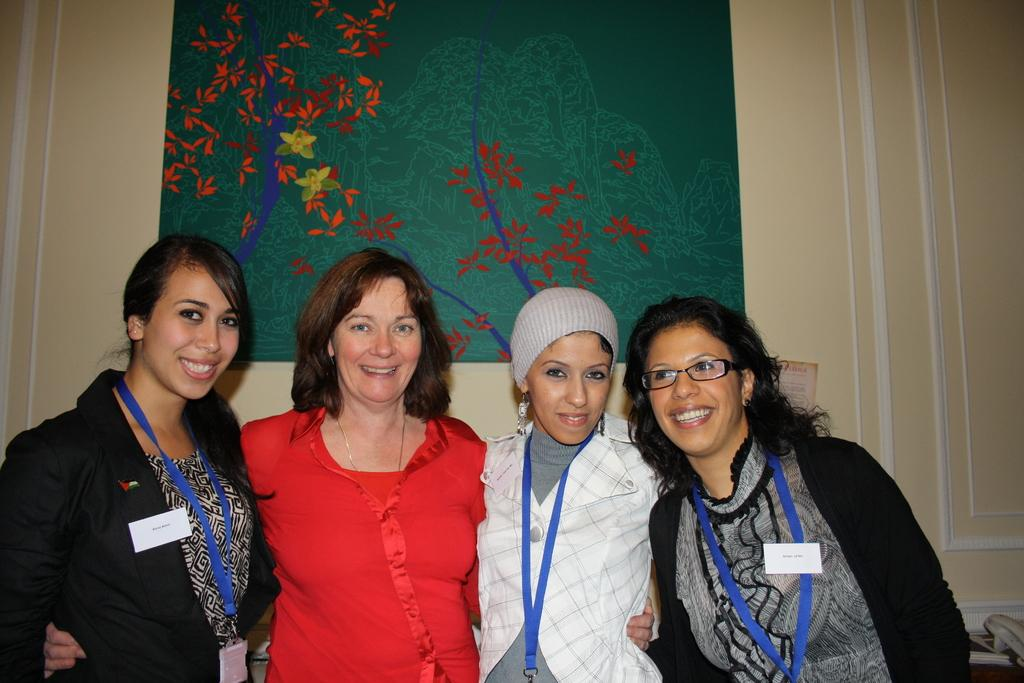Who is the main subject in the image? There is a woman in the image. What is the woman wearing that is visible in the image? The woman is wearing tags. What can be seen in the background of the image? There is a wall in the background of the image. What color is the frame on the wall? The frame on the wall is green-colored. What discovery did the woman make in the image? There is no indication of a discovery in the image; it simply shows a woman wearing tags with a green-colored frame on the wall in the background. 